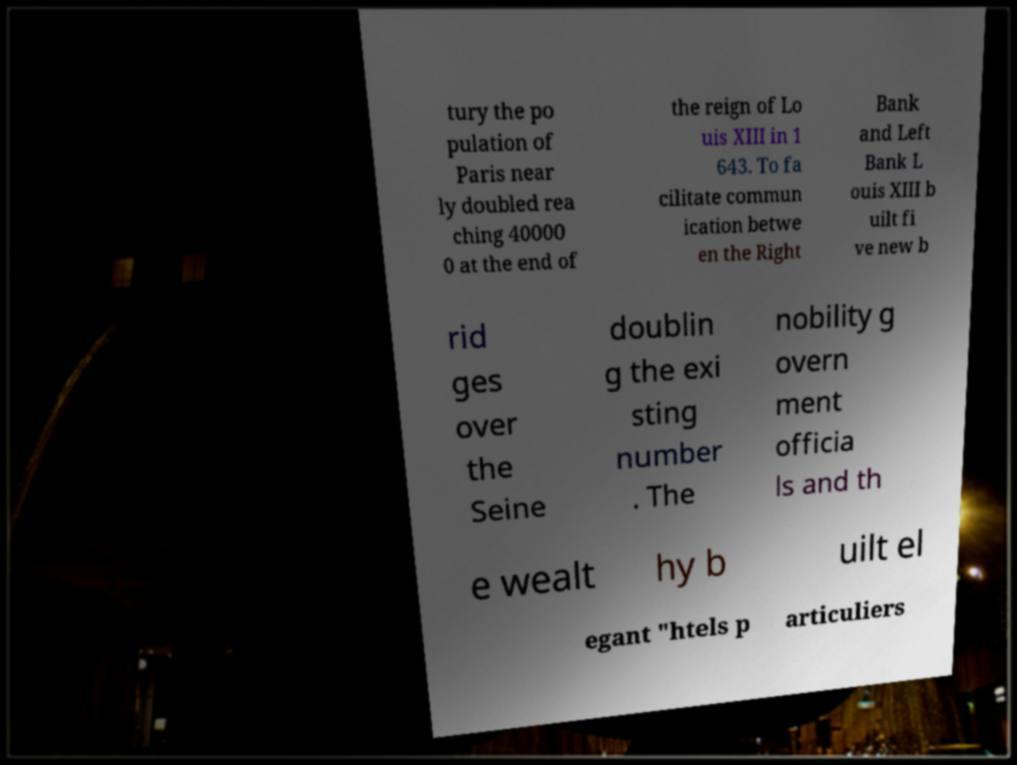Could you assist in decoding the text presented in this image and type it out clearly? tury the po pulation of Paris near ly doubled rea ching 40000 0 at the end of the reign of Lo uis XIII in 1 643. To fa cilitate commun ication betwe en the Right Bank and Left Bank L ouis XIII b uilt fi ve new b rid ges over the Seine doublin g the exi sting number . The nobility g overn ment officia ls and th e wealt hy b uilt el egant "htels p articuliers 